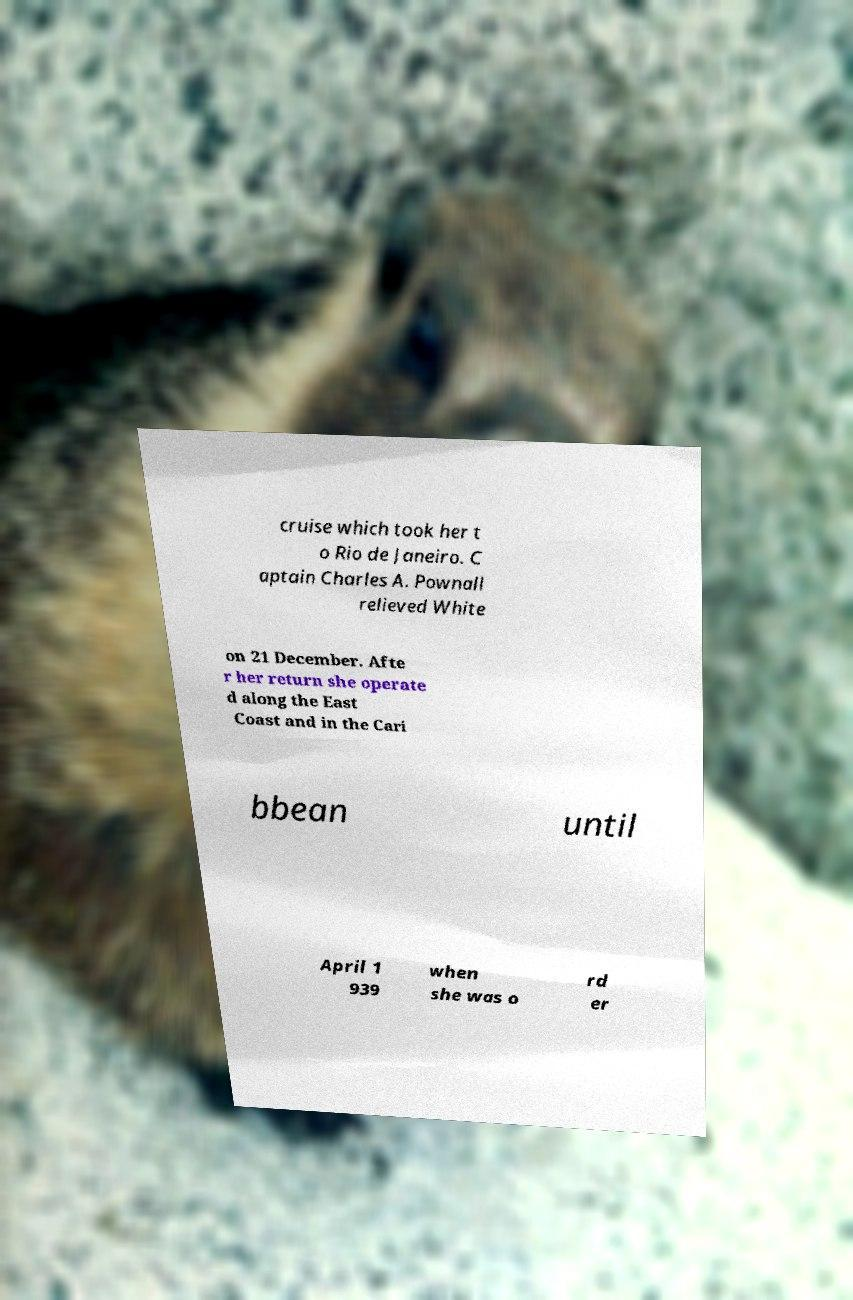Could you assist in decoding the text presented in this image and type it out clearly? cruise which took her t o Rio de Janeiro. C aptain Charles A. Pownall relieved White on 21 December. Afte r her return she operate d along the East Coast and in the Cari bbean until April 1 939 when she was o rd er 